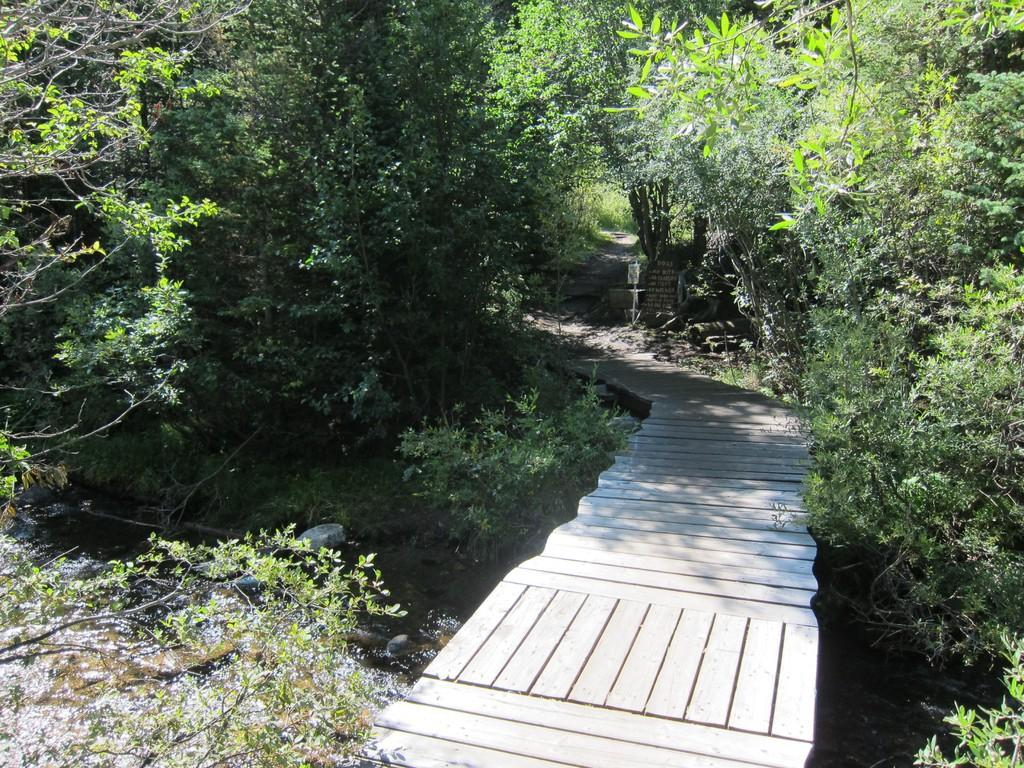What type of vegetation can be seen in the image? There are trees and plants in the image. What body of water is present in the image? There is a canal in the image. Is there any man-made structure visible in the image? Yes, there is a bridge in the image. What type of wrench is being used to repair the cemetery in the image? There is no wrench or cemetery present in the image. 